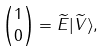Convert formula to latex. <formula><loc_0><loc_0><loc_500><loc_500>\binom { 1 } { 0 } = \widetilde { E } | \widetilde { V } \rangle ,</formula> 